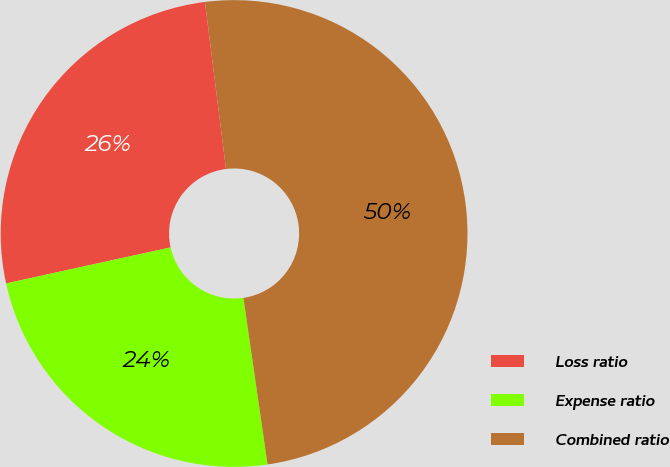Convert chart to OTSL. <chart><loc_0><loc_0><loc_500><loc_500><pie_chart><fcel>Loss ratio<fcel>Expense ratio<fcel>Combined ratio<nl><fcel>26.44%<fcel>23.86%<fcel>49.7%<nl></chart> 